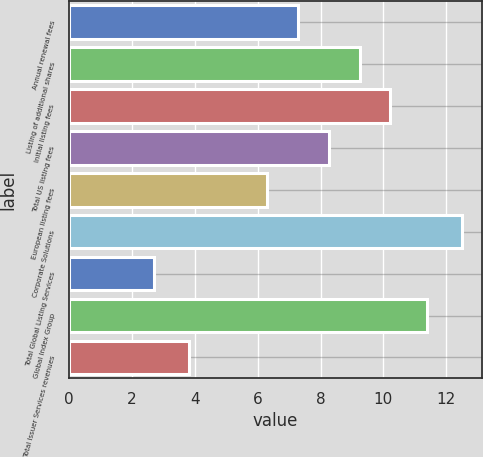Convert chart. <chart><loc_0><loc_0><loc_500><loc_500><bar_chart><fcel>Annual renewal fees<fcel>Listing of additional shares<fcel>Initial listing fees<fcel>Total US listing fees<fcel>European listing fees<fcel>Corporate Solutions<fcel>Total Global Listing Services<fcel>Global Index Group<fcel>Total Issuer Services revenues<nl><fcel>7.28<fcel>9.24<fcel>10.22<fcel>8.26<fcel>6.3<fcel>12.5<fcel>2.7<fcel>11.4<fcel>3.8<nl></chart> 